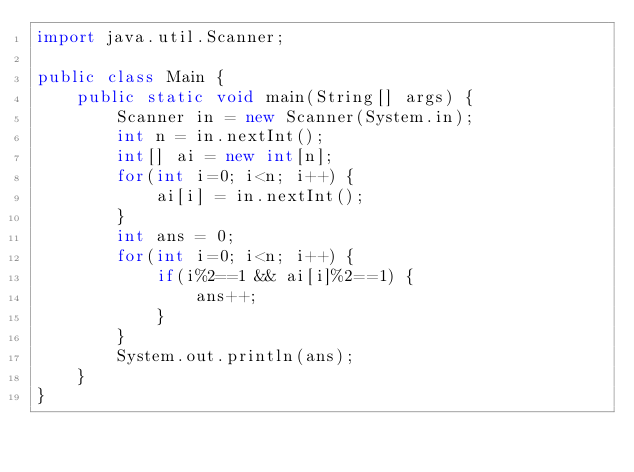<code> <loc_0><loc_0><loc_500><loc_500><_Java_>import java.util.Scanner;

public class Main {
    public static void main(String[] args) {
        Scanner in = new Scanner(System.in);
        int n = in.nextInt();
        int[] ai = new int[n];
        for(int i=0; i<n; i++) {
            ai[i] = in.nextInt();
        }
        int ans = 0;
        for(int i=0; i<n; i++) {
            if(i%2==1 && ai[i]%2==1) {
                ans++;
            }
        }
        System.out.println(ans);
    }
}
</code> 